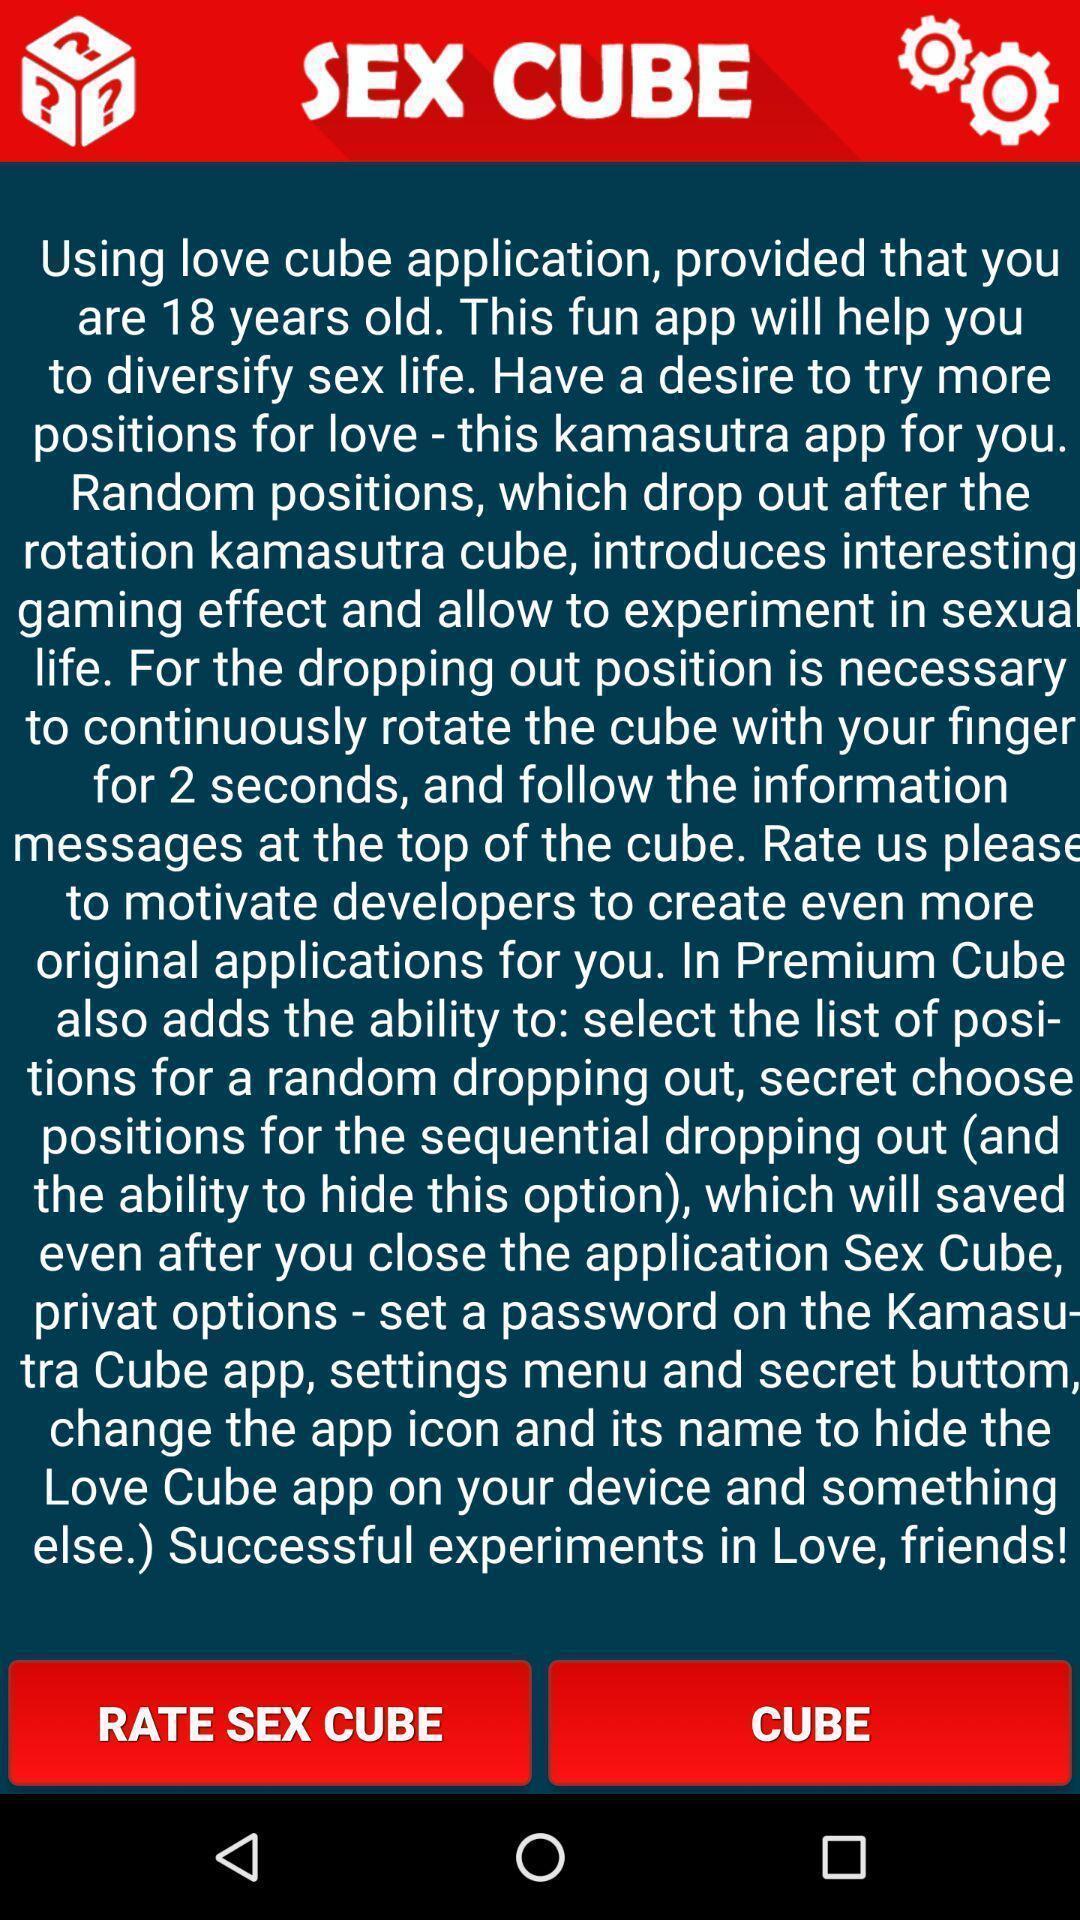Give me a summary of this screen capture. Welcome page for dating based app. 